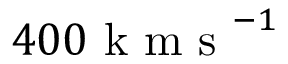Convert formula to latex. <formula><loc_0><loc_0><loc_500><loc_500>4 0 0 k m s ^ { - 1 }</formula> 